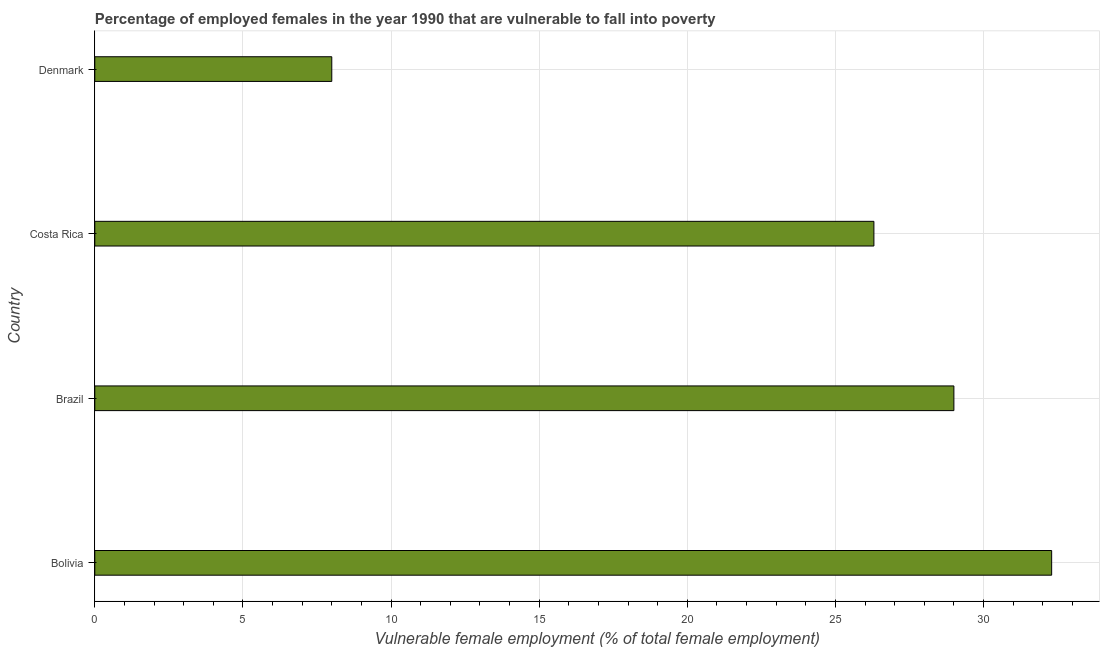Does the graph contain any zero values?
Provide a succinct answer. No. Does the graph contain grids?
Your answer should be very brief. Yes. What is the title of the graph?
Keep it short and to the point. Percentage of employed females in the year 1990 that are vulnerable to fall into poverty. What is the label or title of the X-axis?
Your answer should be very brief. Vulnerable female employment (% of total female employment). What is the label or title of the Y-axis?
Offer a very short reply. Country. Across all countries, what is the maximum percentage of employed females who are vulnerable to fall into poverty?
Keep it short and to the point. 32.3. Across all countries, what is the minimum percentage of employed females who are vulnerable to fall into poverty?
Your answer should be very brief. 8. In which country was the percentage of employed females who are vulnerable to fall into poverty minimum?
Your answer should be compact. Denmark. What is the sum of the percentage of employed females who are vulnerable to fall into poverty?
Provide a short and direct response. 95.6. What is the difference between the percentage of employed females who are vulnerable to fall into poverty in Costa Rica and Denmark?
Provide a succinct answer. 18.3. What is the average percentage of employed females who are vulnerable to fall into poverty per country?
Make the answer very short. 23.9. What is the median percentage of employed females who are vulnerable to fall into poverty?
Ensure brevity in your answer.  27.65. In how many countries, is the percentage of employed females who are vulnerable to fall into poverty greater than 12 %?
Give a very brief answer. 3. What is the ratio of the percentage of employed females who are vulnerable to fall into poverty in Bolivia to that in Brazil?
Your response must be concise. 1.11. Is the difference between the percentage of employed females who are vulnerable to fall into poverty in Costa Rica and Denmark greater than the difference between any two countries?
Ensure brevity in your answer.  No. What is the difference between the highest and the second highest percentage of employed females who are vulnerable to fall into poverty?
Provide a short and direct response. 3.3. Is the sum of the percentage of employed females who are vulnerable to fall into poverty in Bolivia and Costa Rica greater than the maximum percentage of employed females who are vulnerable to fall into poverty across all countries?
Your answer should be compact. Yes. What is the difference between the highest and the lowest percentage of employed females who are vulnerable to fall into poverty?
Provide a succinct answer. 24.3. What is the Vulnerable female employment (% of total female employment) in Bolivia?
Provide a short and direct response. 32.3. What is the Vulnerable female employment (% of total female employment) in Brazil?
Give a very brief answer. 29. What is the Vulnerable female employment (% of total female employment) of Costa Rica?
Make the answer very short. 26.3. What is the difference between the Vulnerable female employment (% of total female employment) in Bolivia and Costa Rica?
Make the answer very short. 6. What is the difference between the Vulnerable female employment (% of total female employment) in Bolivia and Denmark?
Make the answer very short. 24.3. What is the difference between the Vulnerable female employment (% of total female employment) in Brazil and Costa Rica?
Make the answer very short. 2.7. What is the difference between the Vulnerable female employment (% of total female employment) in Costa Rica and Denmark?
Keep it short and to the point. 18.3. What is the ratio of the Vulnerable female employment (% of total female employment) in Bolivia to that in Brazil?
Give a very brief answer. 1.11. What is the ratio of the Vulnerable female employment (% of total female employment) in Bolivia to that in Costa Rica?
Offer a very short reply. 1.23. What is the ratio of the Vulnerable female employment (% of total female employment) in Bolivia to that in Denmark?
Offer a terse response. 4.04. What is the ratio of the Vulnerable female employment (% of total female employment) in Brazil to that in Costa Rica?
Provide a short and direct response. 1.1. What is the ratio of the Vulnerable female employment (% of total female employment) in Brazil to that in Denmark?
Provide a short and direct response. 3.62. What is the ratio of the Vulnerable female employment (% of total female employment) in Costa Rica to that in Denmark?
Your response must be concise. 3.29. 